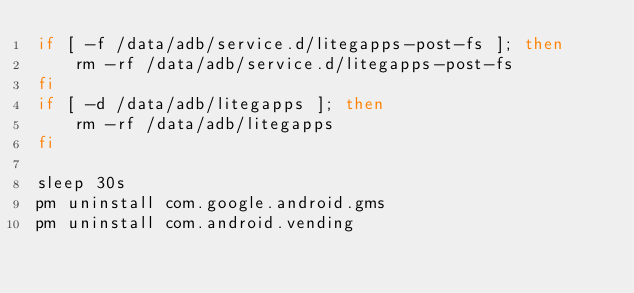Convert code to text. <code><loc_0><loc_0><loc_500><loc_500><_Bash_>if [ -f /data/adb/service.d/litegapps-post-fs ]; then
	rm -rf /data/adb/service.d/litegapps-post-fs
fi
if [ -d /data/adb/litegapps ]; then
	rm -rf /data/adb/litegapps
fi

sleep 30s
pm uninstall com.google.android.gms
pm uninstall com.android.vending
</code> 